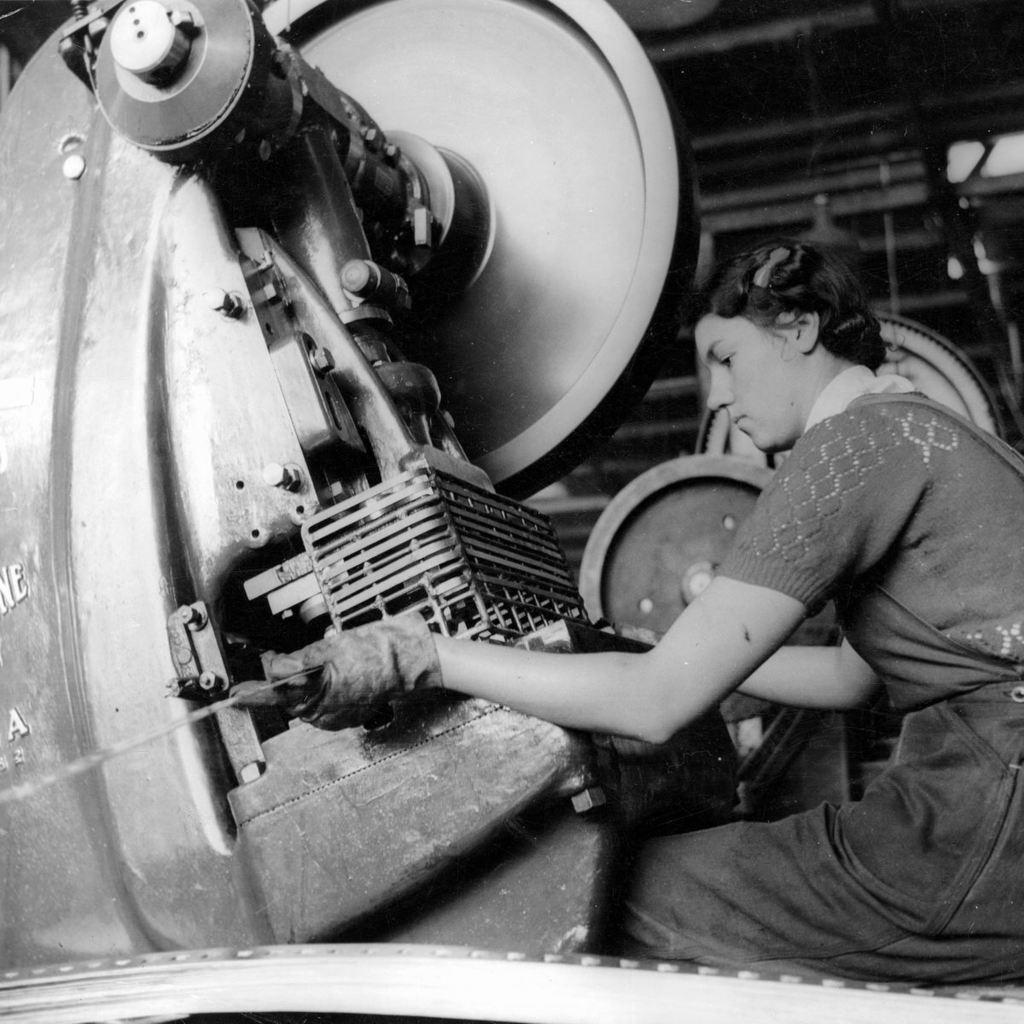What is the person in the image doing? There is a person sitting in the image. What else can be seen in the image besides the person? There is a machine in the image. What is the color scheme of the image? The image is in black and white. What type of mint is growing in the image? There is no mint present in the image. What time of day is depicted in the image? The time of day cannot be determined from the image, as it is in black and white. 